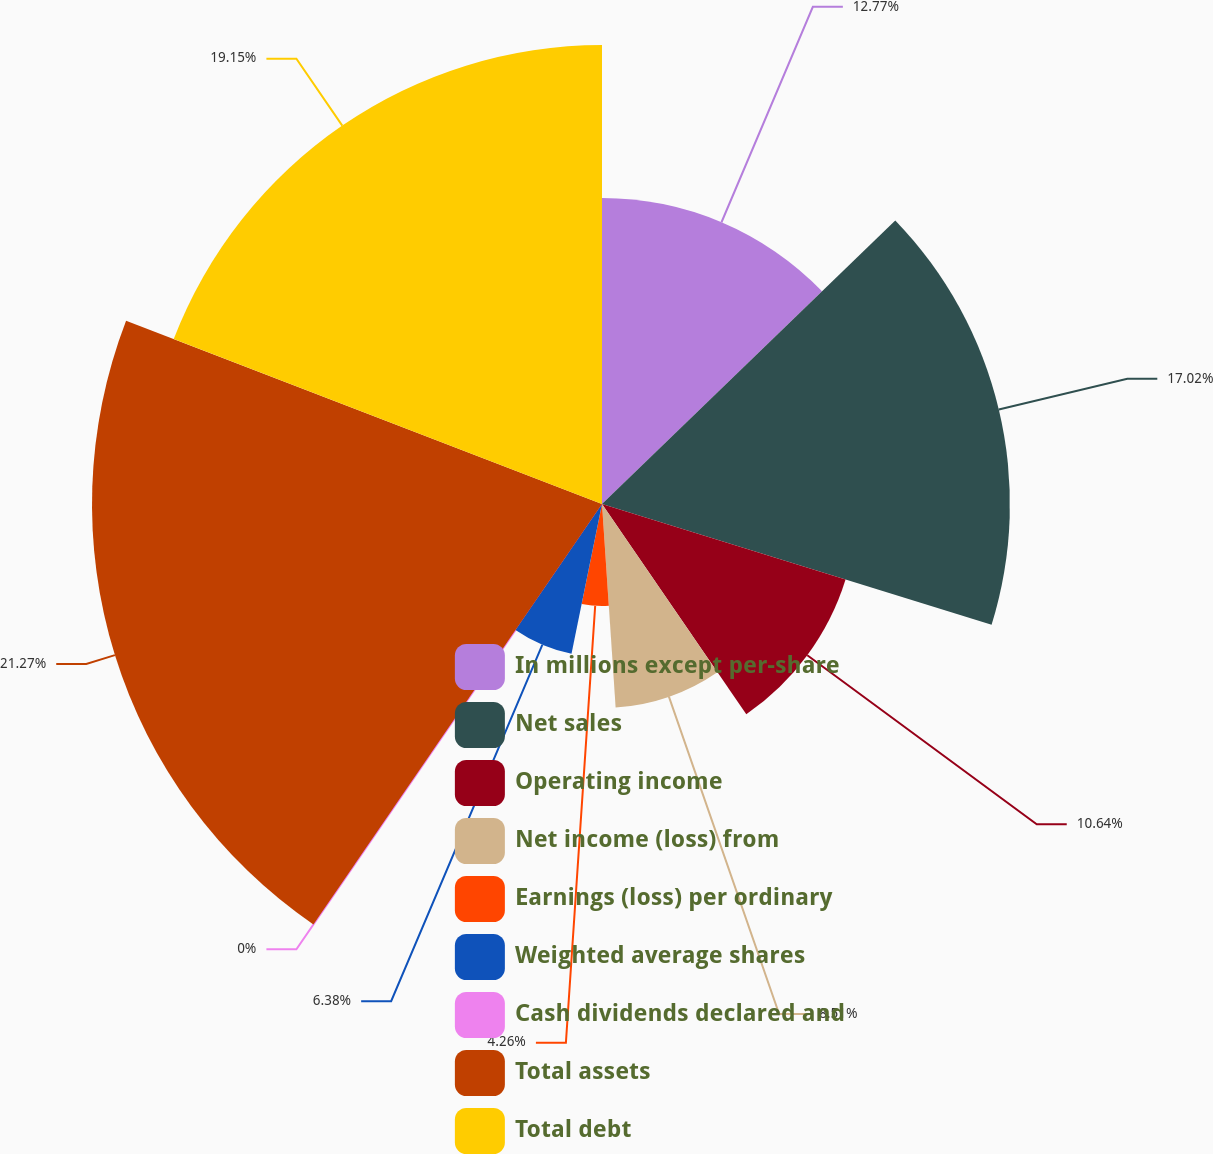Convert chart to OTSL. <chart><loc_0><loc_0><loc_500><loc_500><pie_chart><fcel>In millions except per-share<fcel>Net sales<fcel>Operating income<fcel>Net income (loss) from<fcel>Earnings (loss) per ordinary<fcel>Weighted average shares<fcel>Cash dividends declared and<fcel>Total assets<fcel>Total debt<nl><fcel>12.77%<fcel>17.02%<fcel>10.64%<fcel>8.51%<fcel>4.26%<fcel>6.38%<fcel>0.0%<fcel>21.28%<fcel>19.15%<nl></chart> 